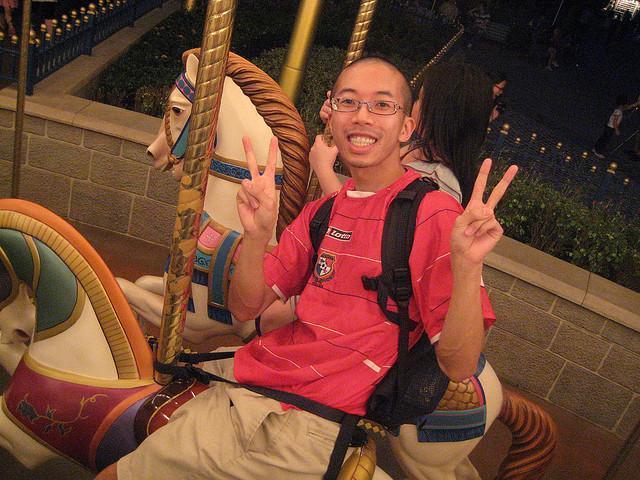How many fingers is he holding up?
Give a very brief answer. 4. How many people are there?
Give a very brief answer. 2. How many horses are there?
Give a very brief answer. 2. How many motorcycles are between the sidewalk and the yellow line in the road?
Give a very brief answer. 0. 